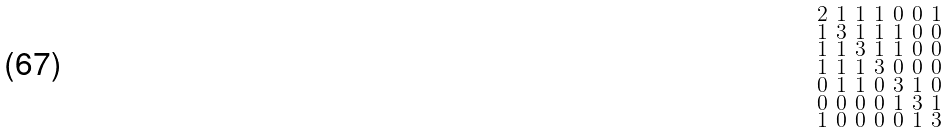Convert formula to latex. <formula><loc_0><loc_0><loc_500><loc_500>\begin{smallmatrix} 2 & 1 & 1 & 1 & 0 & 0 & 1 \\ 1 & 3 & 1 & 1 & 1 & 0 & 0 \\ 1 & 1 & 3 & 1 & 1 & 0 & 0 \\ 1 & 1 & 1 & 3 & 0 & 0 & 0 \\ 0 & 1 & 1 & 0 & 3 & 1 & 0 \\ 0 & 0 & 0 & 0 & 1 & 3 & 1 \\ 1 & 0 & 0 & 0 & 0 & 1 & 3 \end{smallmatrix}</formula> 